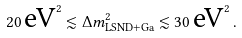Convert formula to latex. <formula><loc_0><loc_0><loc_500><loc_500>2 0 \, \text {eV} ^ { 2 } \lesssim \Delta { m } ^ { 2 } _ { \text {LSND} + \text {Ga} } \lesssim 3 0 \, \text {eV} ^ { 2 } \, .</formula> 